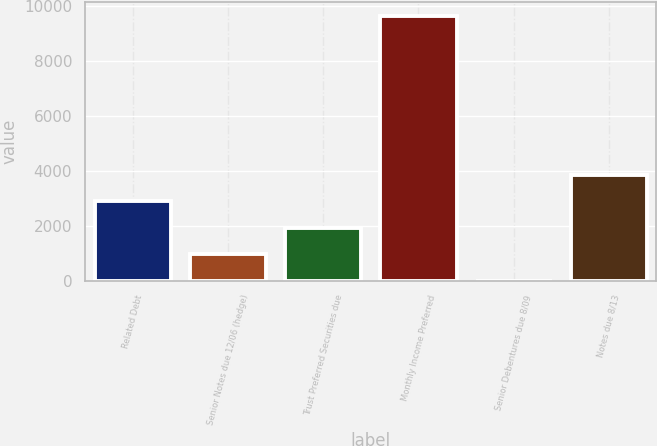Convert chart to OTSL. <chart><loc_0><loc_0><loc_500><loc_500><bar_chart><fcel>Related Debt<fcel>Senior Notes due 12/06 (hedge)<fcel>Trust Preferred Securities due<fcel>Monthly Income Preferred<fcel>Senior Debentures due 8/09<fcel>Notes due 8/13<nl><fcel>2900.52<fcel>966.96<fcel>1933.74<fcel>9668<fcel>0.18<fcel>3867.3<nl></chart> 